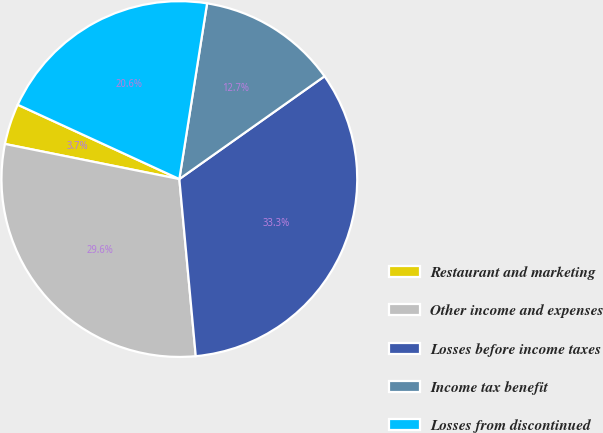Convert chart. <chart><loc_0><loc_0><loc_500><loc_500><pie_chart><fcel>Restaurant and marketing<fcel>Other income and expenses<fcel>Losses before income taxes<fcel>Income tax benefit<fcel>Losses from discontinued<nl><fcel>3.7%<fcel>29.63%<fcel>33.33%<fcel>12.7%<fcel>20.63%<nl></chart> 